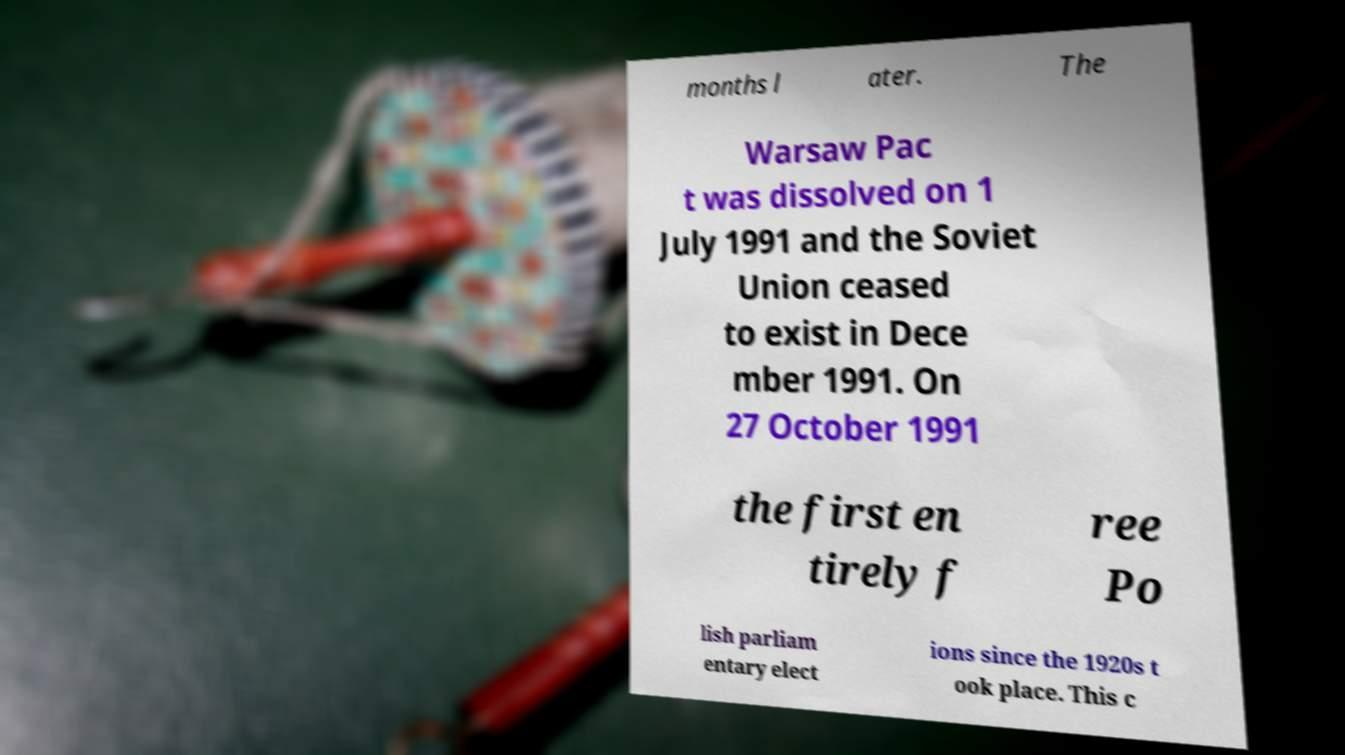What messages or text are displayed in this image? I need them in a readable, typed format. months l ater. The Warsaw Pac t was dissolved on 1 July 1991 and the Soviet Union ceased to exist in Dece mber 1991. On 27 October 1991 the first en tirely f ree Po lish parliam entary elect ions since the 1920s t ook place. This c 